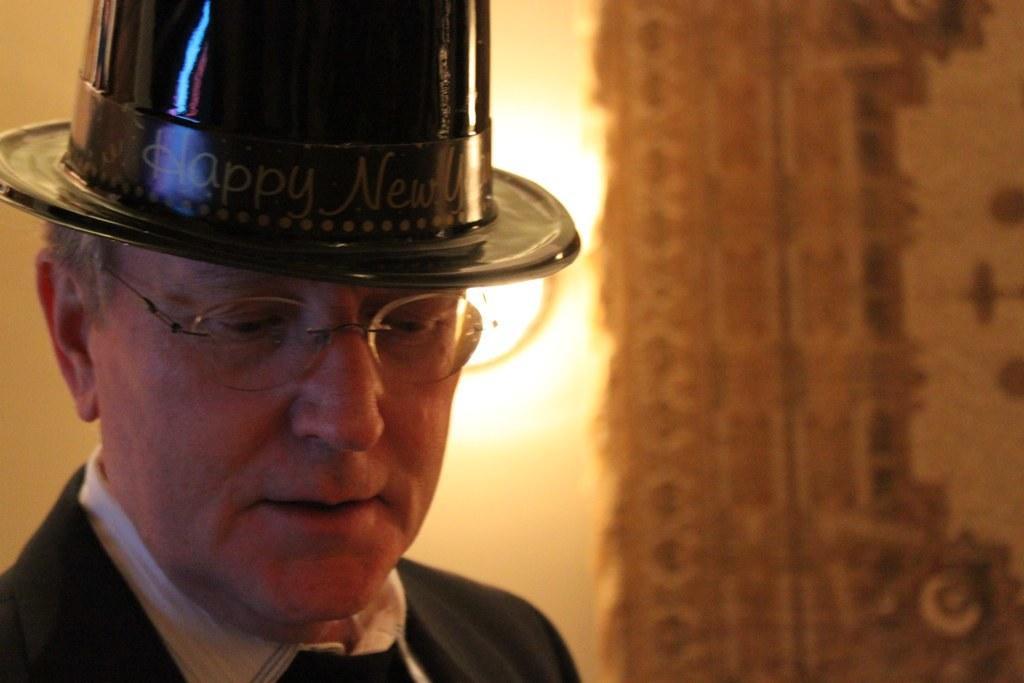Describe this image in one or two sentences. In this image we can see a person. The background of the image is blur. 